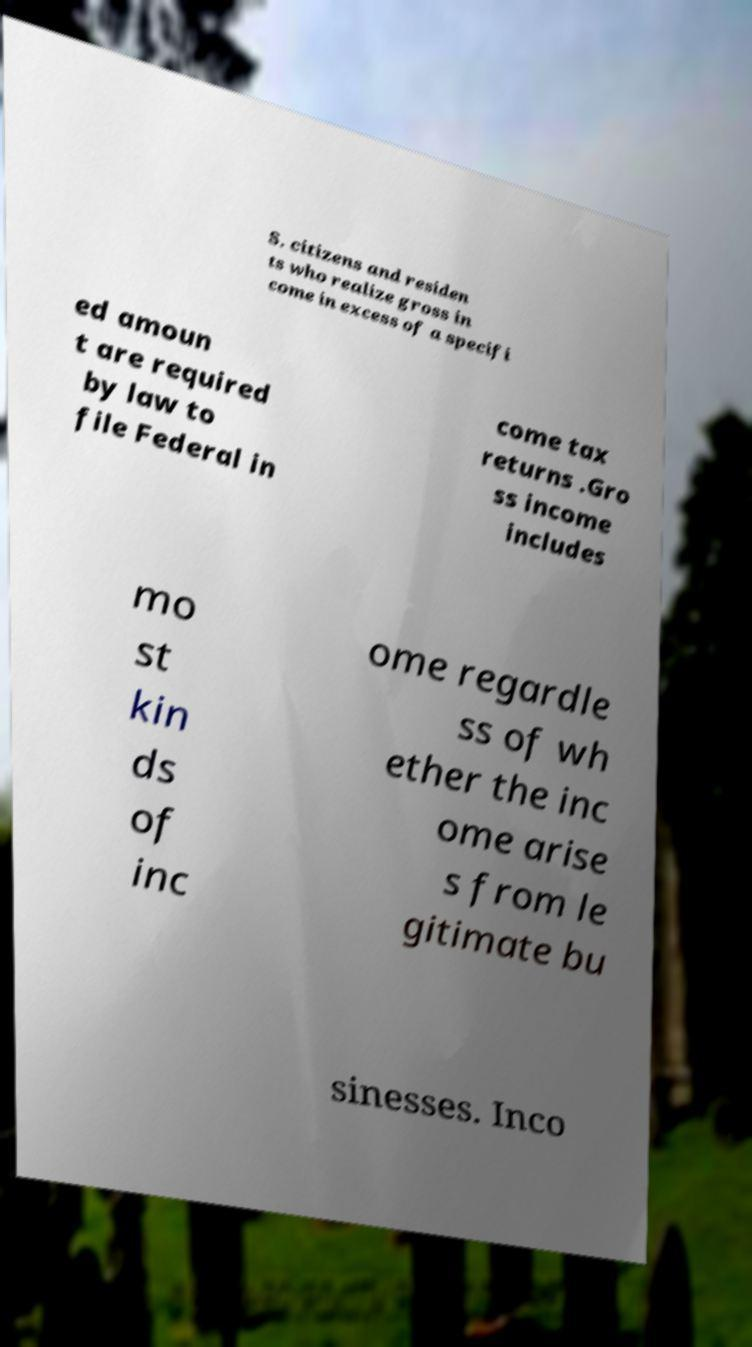Please read and relay the text visible in this image. What does it say? S. citizens and residen ts who realize gross in come in excess of a specifi ed amoun t are required by law to file Federal in come tax returns .Gro ss income includes mo st kin ds of inc ome regardle ss of wh ether the inc ome arise s from le gitimate bu sinesses. Inco 